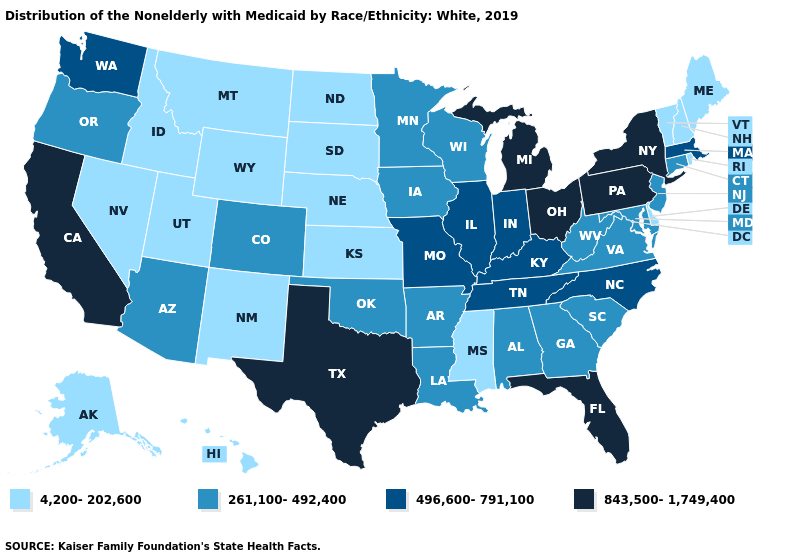Does the first symbol in the legend represent the smallest category?
Be succinct. Yes. What is the highest value in the USA?
Write a very short answer. 843,500-1,749,400. What is the value of Maryland?
Quick response, please. 261,100-492,400. Does the map have missing data?
Keep it brief. No. Does Connecticut have a higher value than Texas?
Write a very short answer. No. Name the states that have a value in the range 261,100-492,400?
Keep it brief. Alabama, Arizona, Arkansas, Colorado, Connecticut, Georgia, Iowa, Louisiana, Maryland, Minnesota, New Jersey, Oklahoma, Oregon, South Carolina, Virginia, West Virginia, Wisconsin. What is the value of Wisconsin?
Quick response, please. 261,100-492,400. Among the states that border South Dakota , does Iowa have the highest value?
Keep it brief. Yes. Among the states that border Colorado , does Kansas have the lowest value?
Keep it brief. Yes. What is the value of North Dakota?
Short answer required. 4,200-202,600. Name the states that have a value in the range 496,600-791,100?
Concise answer only. Illinois, Indiana, Kentucky, Massachusetts, Missouri, North Carolina, Tennessee, Washington. What is the highest value in the MidWest ?
Answer briefly. 843,500-1,749,400. What is the value of Alaska?
Give a very brief answer. 4,200-202,600. Does Colorado have a higher value than North Dakota?
Write a very short answer. Yes. Name the states that have a value in the range 843,500-1,749,400?
Keep it brief. California, Florida, Michigan, New York, Ohio, Pennsylvania, Texas. 